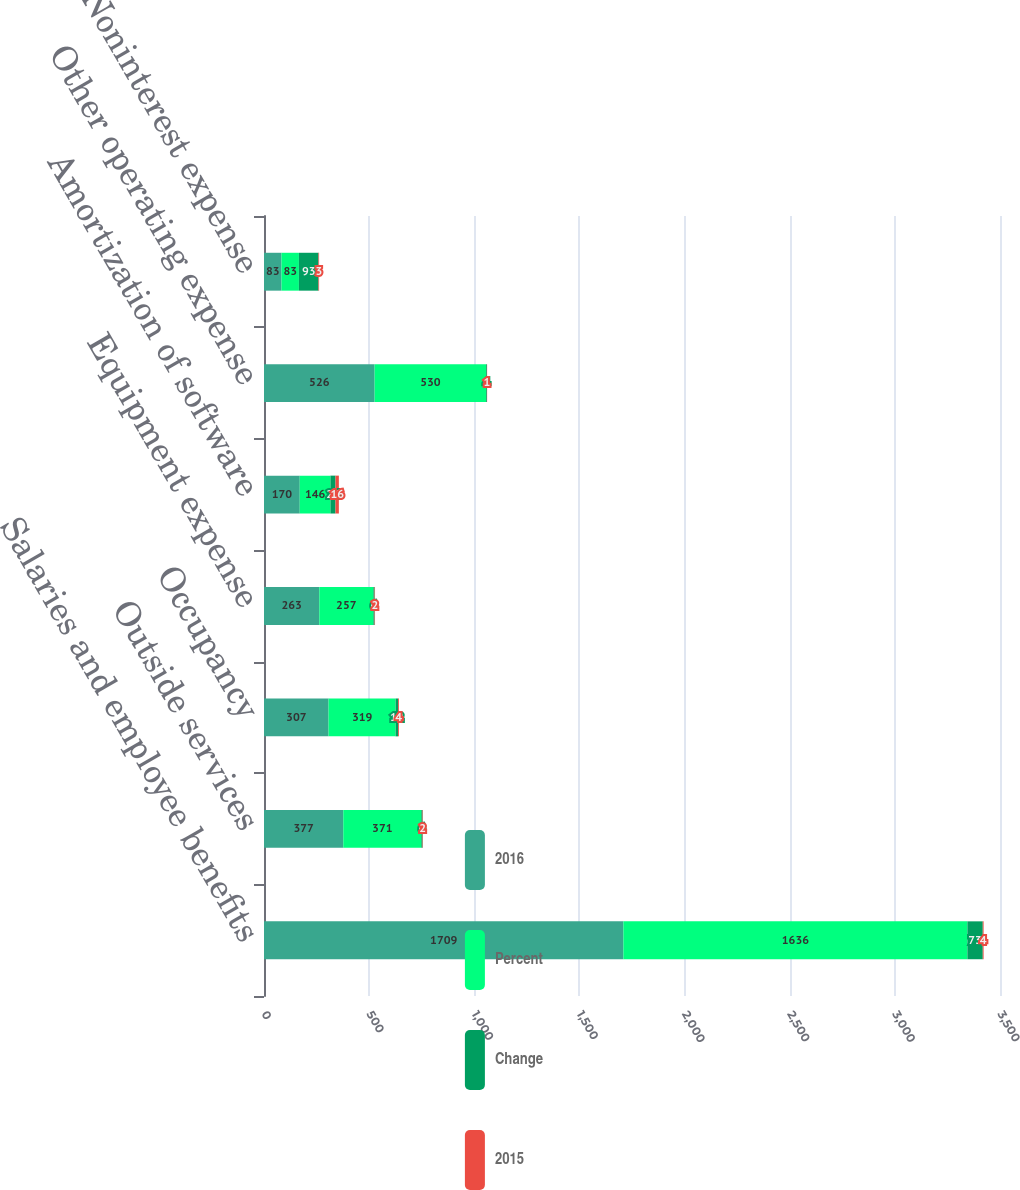Convert chart. <chart><loc_0><loc_0><loc_500><loc_500><stacked_bar_chart><ecel><fcel>Salaries and employee benefits<fcel>Outside services<fcel>Occupancy<fcel>Equipment expense<fcel>Amortization of software<fcel>Other operating expense<fcel>Noninterest expense<nl><fcel>2016<fcel>1709<fcel>377<fcel>307<fcel>263<fcel>170<fcel>526<fcel>83<nl><fcel>Percent<fcel>1636<fcel>371<fcel>319<fcel>257<fcel>146<fcel>530<fcel>83<nl><fcel>Change<fcel>73<fcel>6<fcel>12<fcel>6<fcel>24<fcel>4<fcel>93<nl><fcel>2015<fcel>4<fcel>2<fcel>4<fcel>2<fcel>16<fcel>1<fcel>3<nl></chart> 